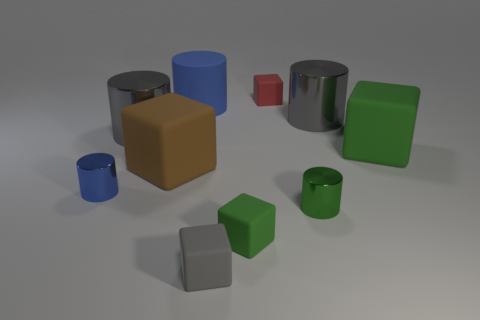How does the texture of the objects differ in this image? The objects in the image display a variety of textures. The blue and green cylinders appear to have a matte, non-reflective surface, suggesting they might be made of a substance like plastic or painted metal. In contrast, the grey cylinder has a shiny, reflective surface that indicates it could be made of polished metal or chrome. The texture differences contribute to the visual interest and could provide insights into the materials represented. 